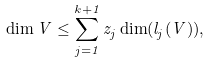Convert formula to latex. <formula><loc_0><loc_0><loc_500><loc_500>\dim V \leq \sum _ { j = 1 } ^ { k + 1 } z _ { j } \dim ( l _ { j } ( V ) ) ,</formula> 